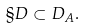<formula> <loc_0><loc_0><loc_500><loc_500>\S D \subset D _ { A } .</formula> 